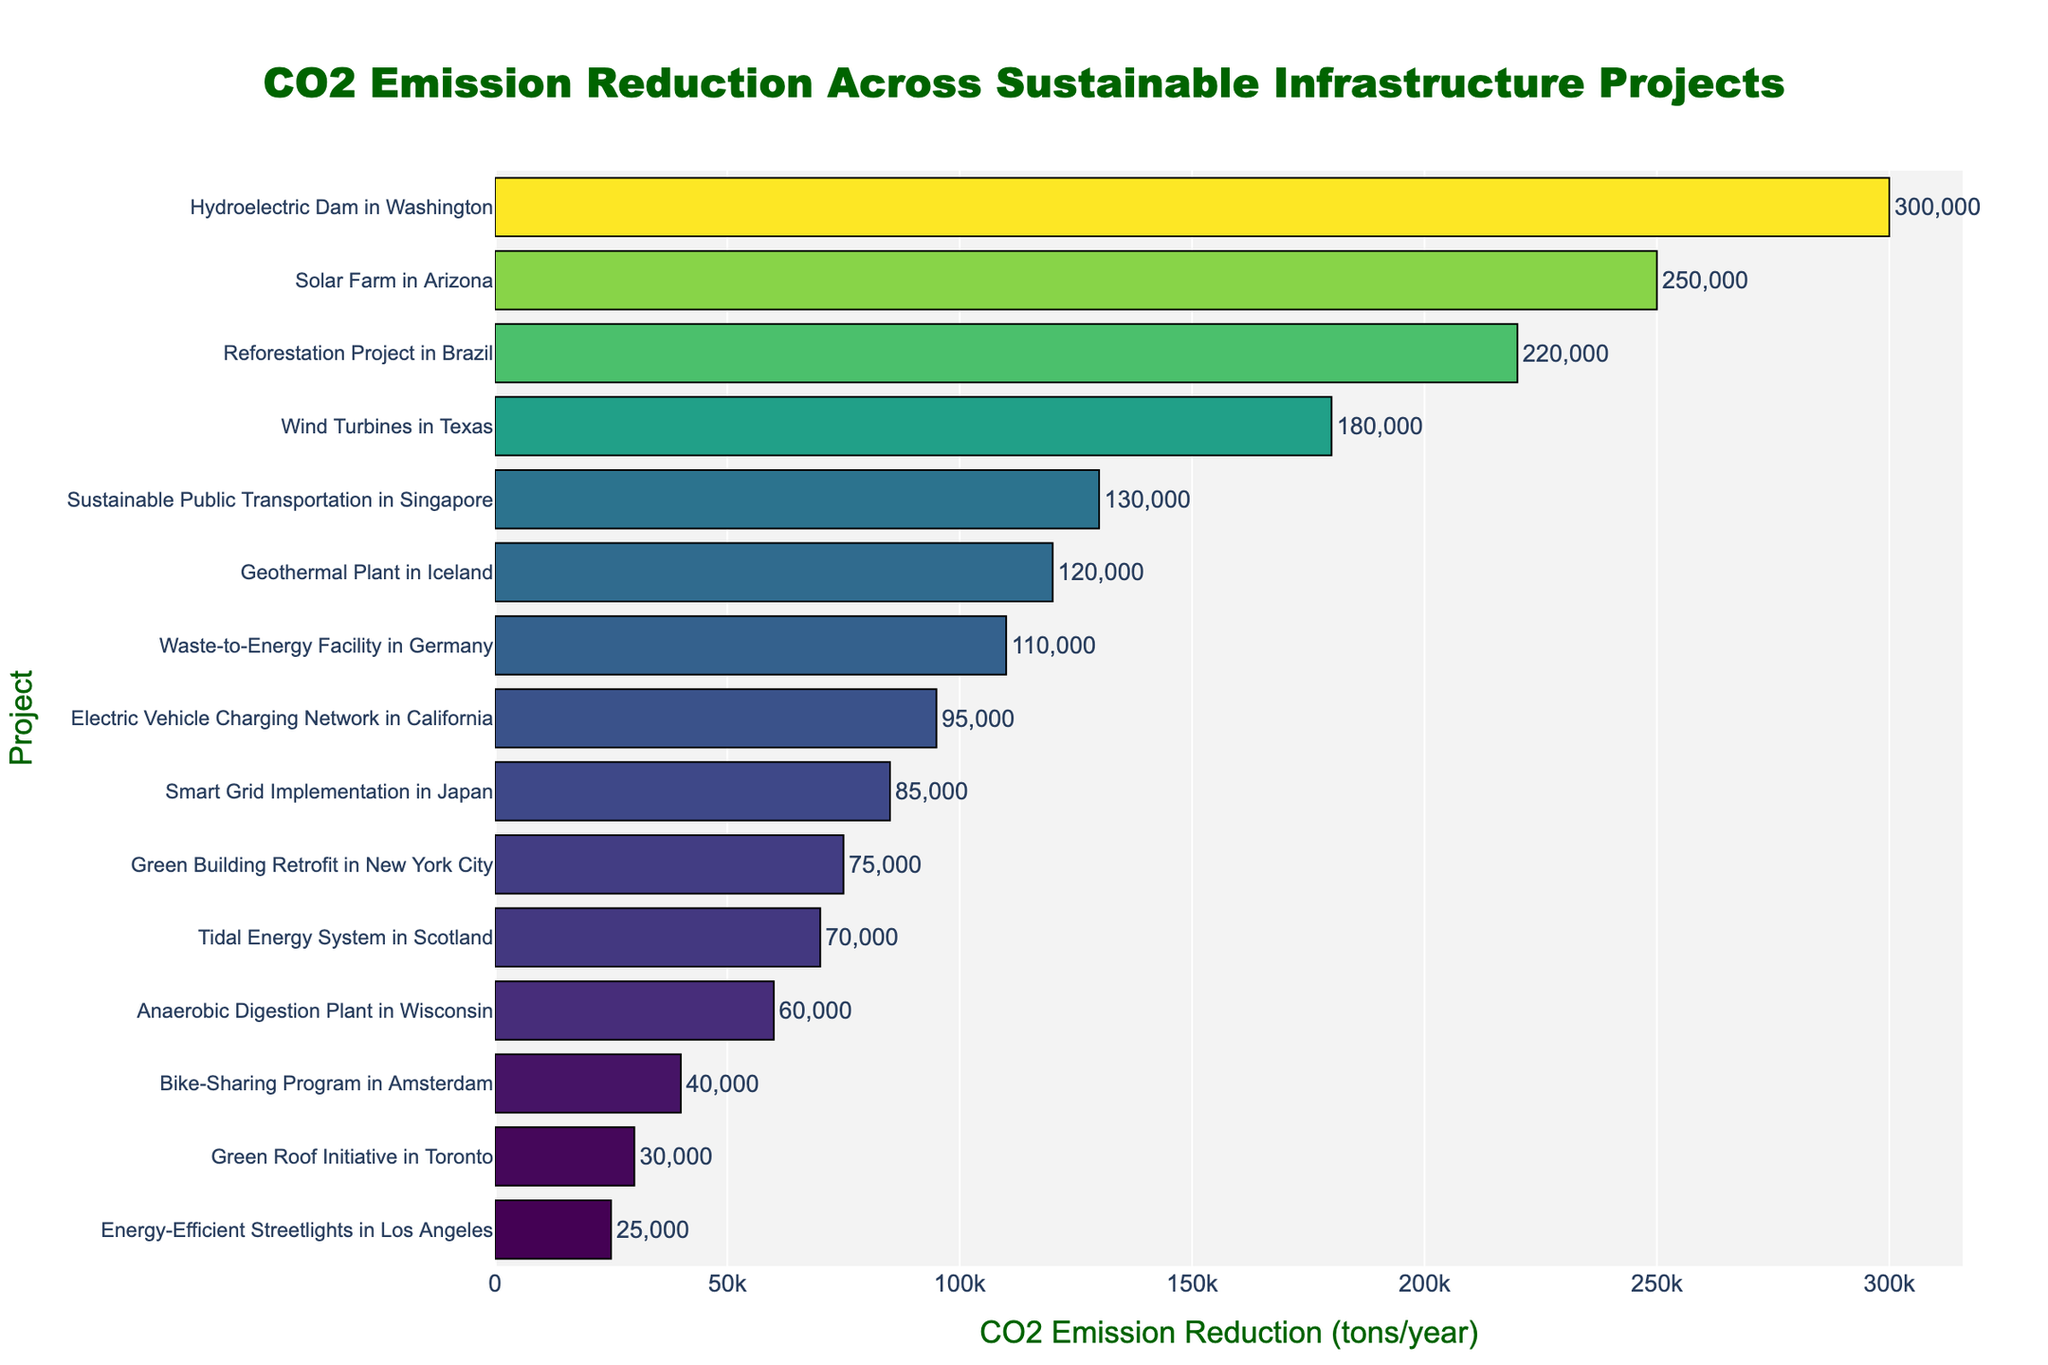What project achieves the highest annual CO2 emission reduction? The figure shows the CO2 emission reductions for each project using horizontal bars. The bar representing the Hydroelectric Dam in Washington is the longest, signifying the highest reduction.
Answer: Hydroelectric Dam in Washington Which project achieves the lowest annual CO2 emission reduction? By looking at the length of the bars, the shortest bar represents the Energy-Efficient Streetlights in Los Angeles, indicating it has the lowest CO2 emission reduction.
Answer: Energy-Efficient Streetlights in Los Angeles What is the total annual CO2 emission reduction achieved by the Solar Farm in Arizona and the Reforestation Project in Brazil? Add the values indicated for both projects: 250,000 (Solar Farm) + 220,000 (Reforestation) = 470,000 tons/year.
Answer: 470,000 tons/year Which projects achieve an annual CO2 emission reduction of more than 200,000 tons? Identify the projects with bars longer than the 200,000 mark. These projects are the Hydroelectric Dam in Washington, Solar Farm in Arizona, and Reforestation Project in Brazil.
Answer: Hydroelectric Dam in Washington, Solar Farm in Arizona, Reforestation Project in Brazil How does the CO2 emission reduction for the Electric Vehicle Charging Network in California compare to the Smart Grid Implementation in Japan? Compare the lengths and values of the bars for these projects. The Electric Vehicle Charging Network in California reduces 95,000 tons/year, which is more than the 85,000 tons/year by Smart Grid Implementation in Japan.
Answer: Electric Vehicle Charging Network in California reduces more What is the difference in CO2 emission reduction between the Geothermal Plant in Iceland and the Waste-to-Energy Facility in Germany? Subtract the values shown for each project: 120,000 (Geothermal Plant) - 110,000 (Waste-to-Energy Facility) = 10,000 tons/year.
Answer: 10,000 tons/year What is the median CO2 emission reduction value among all the projects listed? Arrange the CO2 emission reductions in ascending order and find the middle value. The sorted reductions are 25,000, 30,000, 40,000, 60,000, 70,000, 75,000, 85,000, 95,000, 110,000, 120,000, 130,000, 180,000, 220,000, 250,000, 300,000. The middle value is the 8th one: 85,000 tons/year.
Answer: 85,000 tons/year How much more CO2 is reduced by the Wind Turbines in Texas compared to the Green Building Retrofit in New York City? Subtract the CO2 reduction of Green Building Retrofit (75,000 tons/year) from that of Wind Turbines (180,000 tons/year): 180,000 - 75,000 = 105,000 tons/year.
Answer: 105,000 tons/year What is the average annual CO2 emission reduction among the bottom five projects? Add the reductions of the bottom five projects and divide by five: (25,000 + 30,000 + 40,000 + 60,000 + 70,000) = 225,000 / 5 = 45,000 tons/year.
Answer: 45,000 tons/year 